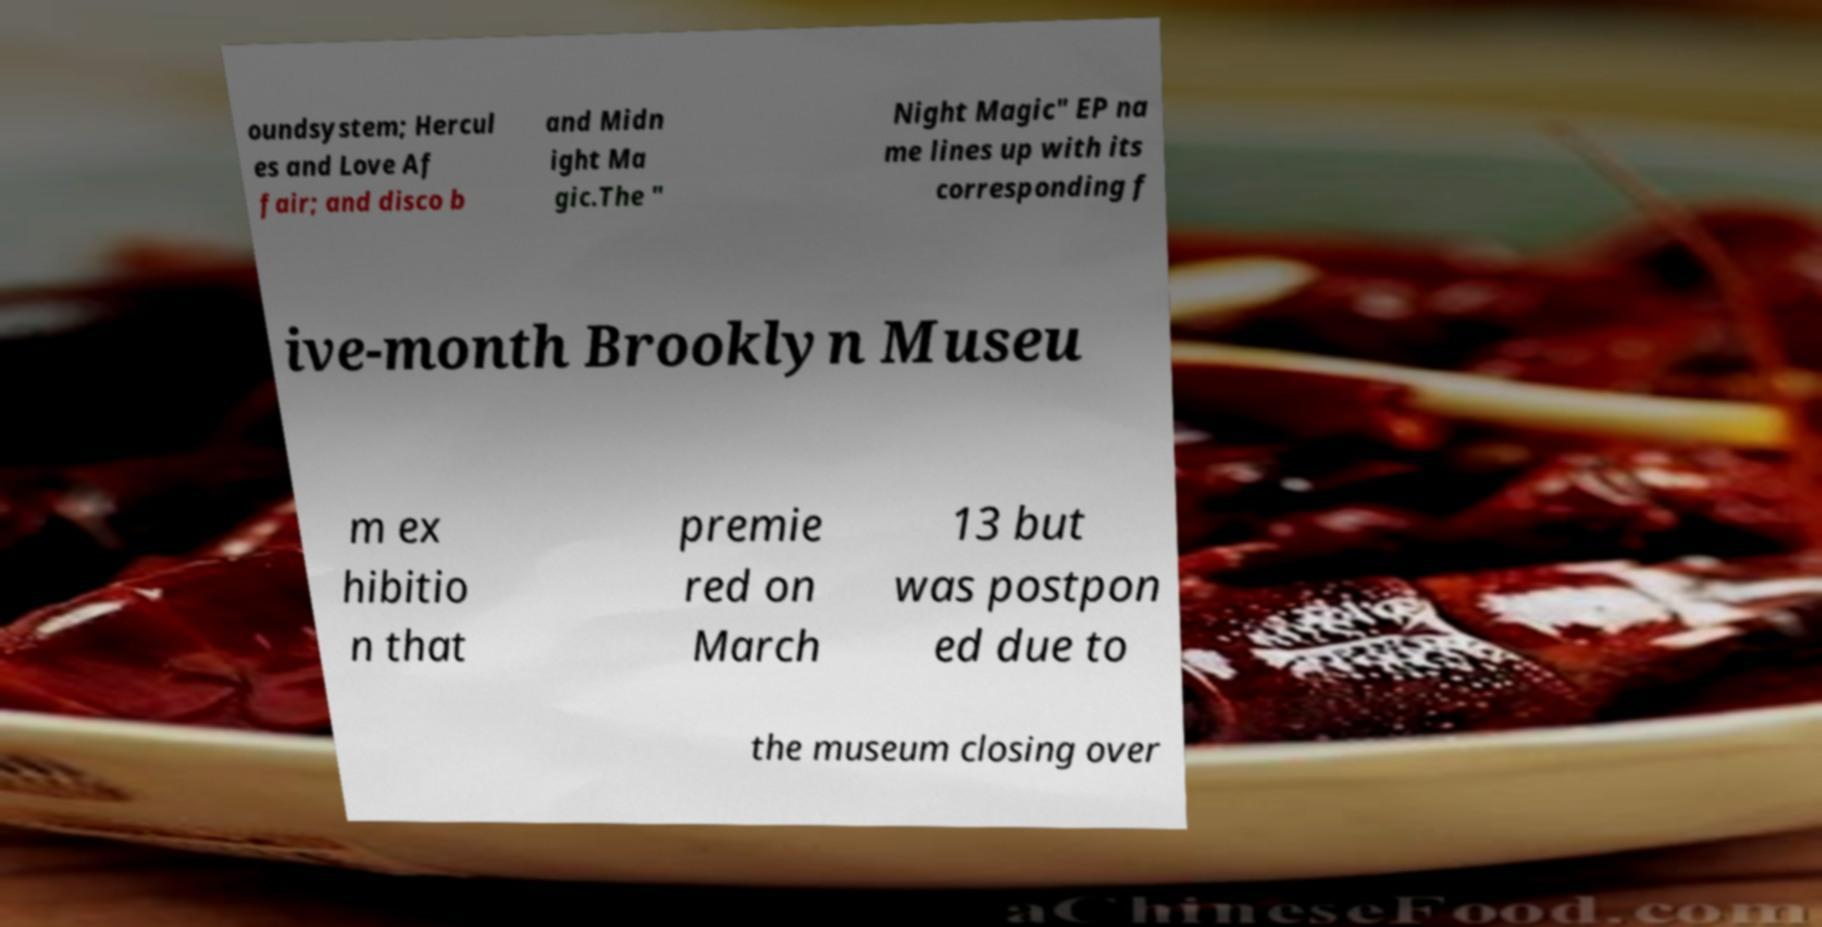For documentation purposes, I need the text within this image transcribed. Could you provide that? oundsystem; Hercul es and Love Af fair; and disco b and Midn ight Ma gic.The " Night Magic" EP na me lines up with its corresponding f ive-month Brooklyn Museu m ex hibitio n that premie red on March 13 but was postpon ed due to the museum closing over 